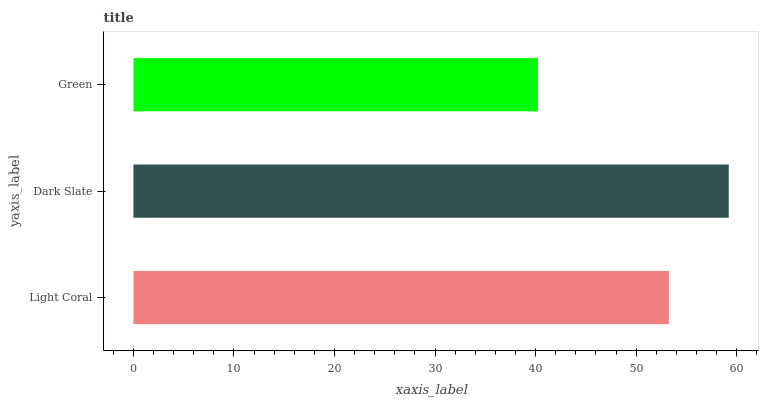Is Green the minimum?
Answer yes or no. Yes. Is Dark Slate the maximum?
Answer yes or no. Yes. Is Dark Slate the minimum?
Answer yes or no. No. Is Green the maximum?
Answer yes or no. No. Is Dark Slate greater than Green?
Answer yes or no. Yes. Is Green less than Dark Slate?
Answer yes or no. Yes. Is Green greater than Dark Slate?
Answer yes or no. No. Is Dark Slate less than Green?
Answer yes or no. No. Is Light Coral the high median?
Answer yes or no. Yes. Is Light Coral the low median?
Answer yes or no. Yes. Is Dark Slate the high median?
Answer yes or no. No. Is Green the low median?
Answer yes or no. No. 